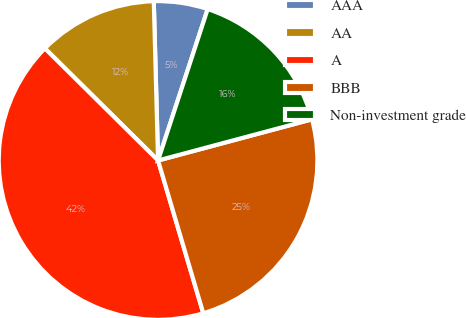<chart> <loc_0><loc_0><loc_500><loc_500><pie_chart><fcel>AAA<fcel>AA<fcel>A<fcel>BBB<fcel>Non-investment grade<nl><fcel>5.47%<fcel>12.15%<fcel>42.0%<fcel>24.58%<fcel>15.8%<nl></chart> 